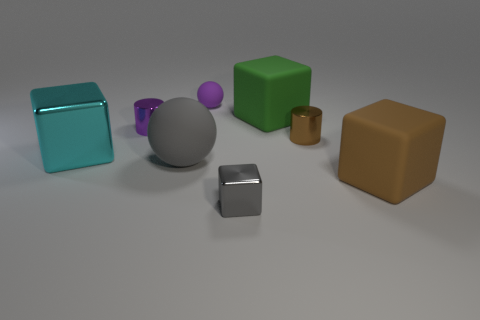Subtract all blue blocks. Subtract all brown cylinders. How many blocks are left? 4 Add 2 big cyan objects. How many objects exist? 10 Subtract all cylinders. How many objects are left? 6 Subtract all rubber balls. Subtract all small shiny blocks. How many objects are left? 5 Add 8 matte balls. How many matte balls are left? 10 Add 4 cyan balls. How many cyan balls exist? 4 Subtract 0 blue blocks. How many objects are left? 8 